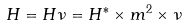Convert formula to latex. <formula><loc_0><loc_0><loc_500><loc_500>H = H \nu = H ^ { * } \times m ^ { 2 } \times \nu</formula> 